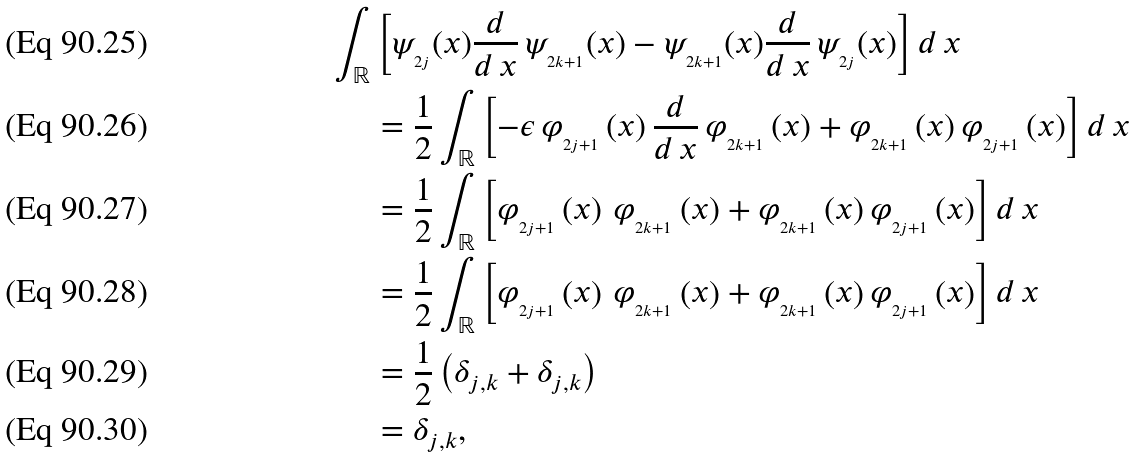Convert formula to latex. <formula><loc_0><loc_0><loc_500><loc_500>\int _ { \mathbb { R } } & \left [ \psi _ { _ { 2 j } } ( x ) \frac { d } { d \, x } \, \psi _ { _ { 2 k + 1 } } ( x ) - \psi _ { _ { 2 k + 1 } } ( x ) \frac { d } { d \, x } \, \psi _ { _ { 2 j } } ( x ) \right ] d \, x \\ & = \frac { 1 } { 2 } \int _ { \mathbb { R } } \left [ - \epsilon \, \varphi _ { _ { 2 j + 1 } } \left ( x \right ) \frac { d } { d \, x } \, \varphi _ { _ { 2 k + 1 } } \left ( x \right ) + \varphi _ { _ { 2 k + 1 } } \left ( x \right ) \varphi _ { _ { 2 j + 1 } } \left ( x \right ) \right ] d \, x \\ & = \frac { 1 } { 2 } \int _ { \mathbb { R } } \left [ \varphi _ { _ { 2 j + 1 } } \left ( x \right ) \, \varphi _ { _ { 2 k + 1 } } \left ( x \right ) + \varphi _ { _ { 2 k + 1 } } \left ( x \right ) \varphi _ { _ { 2 j + 1 } } \left ( x \right ) \right ] d \, x \\ & = \frac { 1 } { 2 } \int _ { \mathbb { R } } \left [ \varphi _ { _ { 2 j + 1 } } \left ( x \right ) \, \varphi _ { _ { 2 k + 1 } } \left ( x \right ) + \varphi _ { _ { 2 k + 1 } } \left ( x \right ) \varphi _ { _ { 2 j + 1 } } \left ( x \right ) \right ] d \, x \\ & = \frac { 1 } { 2 } \left ( \delta _ { j , k } + \delta _ { j , k } \right ) \\ & = \delta _ { j , k } ,</formula> 